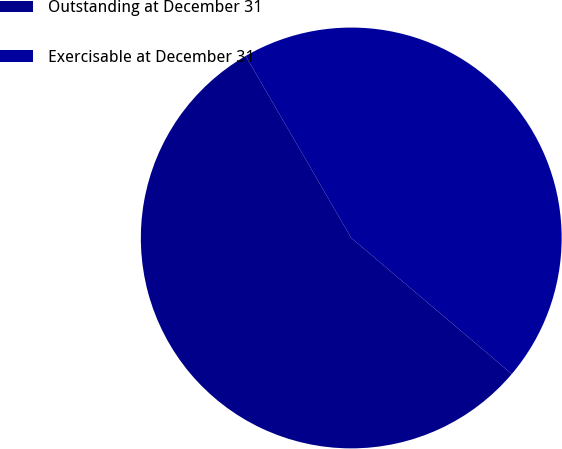Convert chart. <chart><loc_0><loc_0><loc_500><loc_500><pie_chart><fcel>Outstanding at December 31<fcel>Exercisable at December 31<nl><fcel>55.45%<fcel>44.55%<nl></chart> 